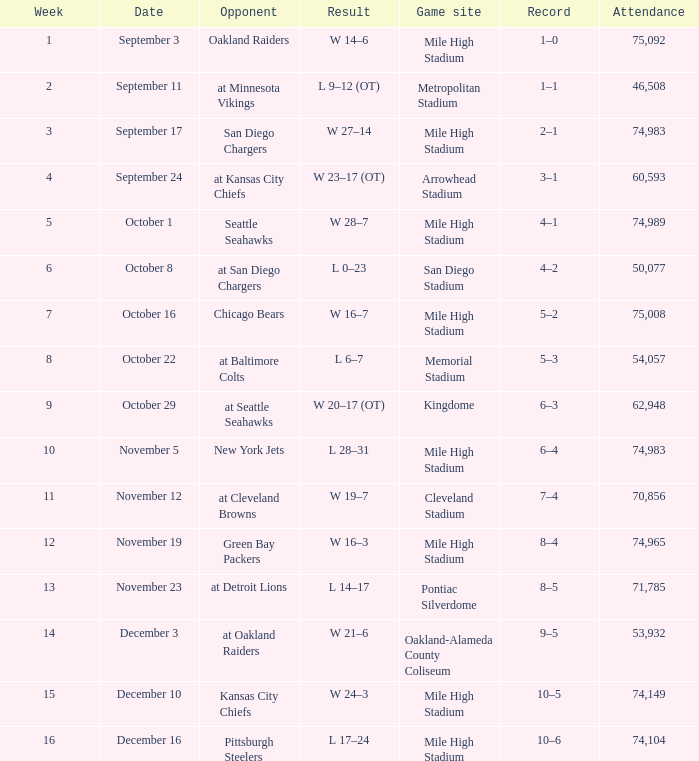In which week is there a 5–2 record? 7.0. 